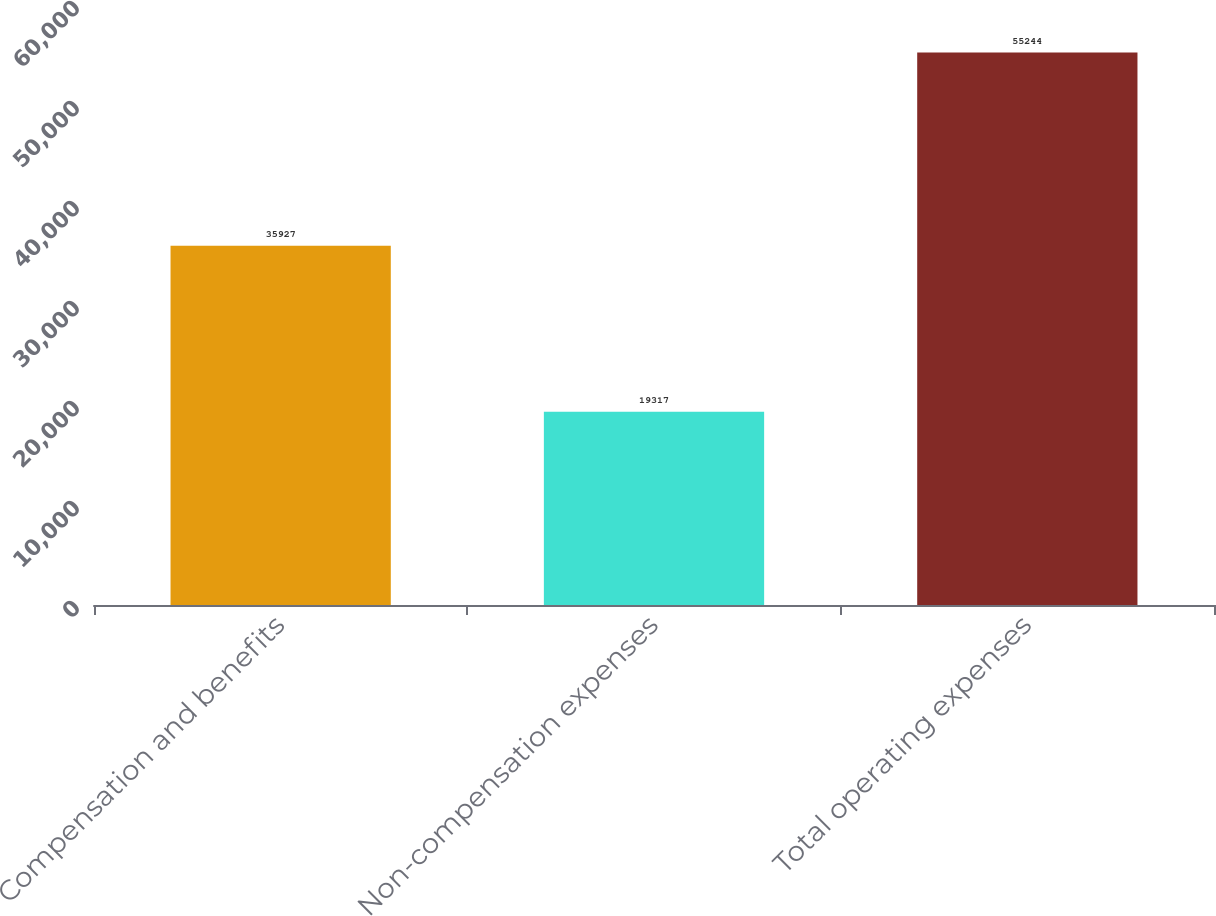Convert chart to OTSL. <chart><loc_0><loc_0><loc_500><loc_500><bar_chart><fcel>Compensation and benefits<fcel>Non-compensation expenses<fcel>Total operating expenses<nl><fcel>35927<fcel>19317<fcel>55244<nl></chart> 